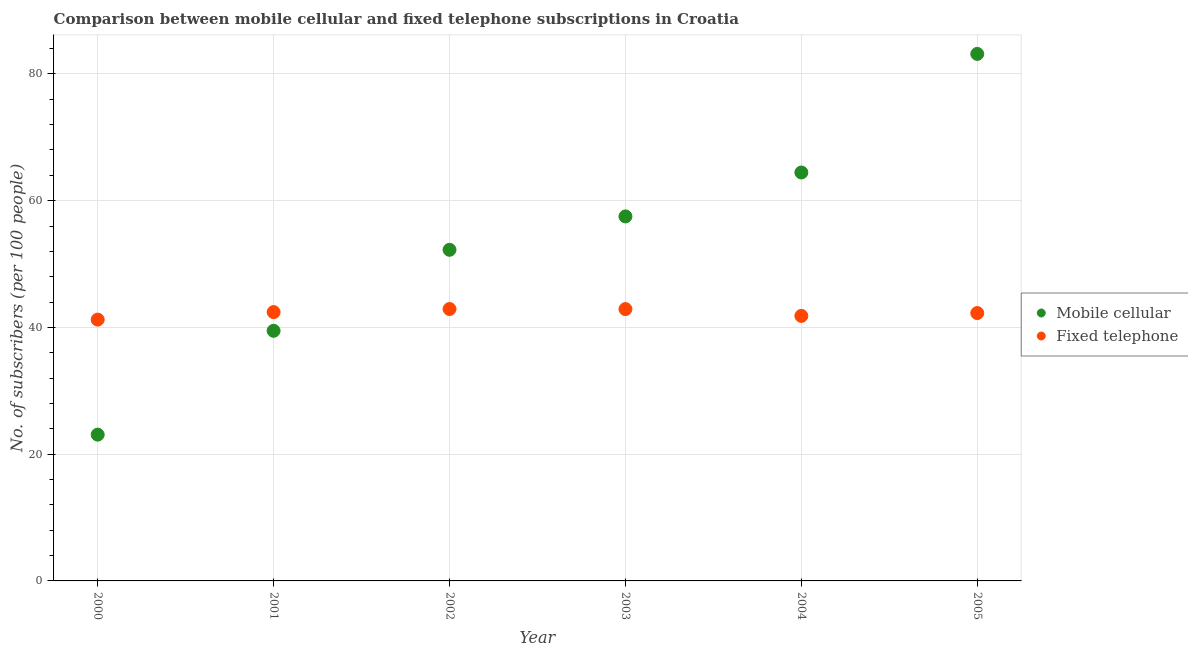Is the number of dotlines equal to the number of legend labels?
Your answer should be very brief. Yes. What is the number of fixed telephone subscribers in 2003?
Make the answer very short. 42.89. Across all years, what is the maximum number of mobile cellular subscribers?
Offer a terse response. 83.16. Across all years, what is the minimum number of fixed telephone subscribers?
Your answer should be very brief. 41.23. In which year was the number of fixed telephone subscribers maximum?
Keep it short and to the point. 2002. In which year was the number of fixed telephone subscribers minimum?
Provide a succinct answer. 2000. What is the total number of fixed telephone subscribers in the graph?
Your response must be concise. 253.53. What is the difference between the number of mobile cellular subscribers in 2000 and that in 2001?
Your answer should be compact. -16.38. What is the difference between the number of mobile cellular subscribers in 2001 and the number of fixed telephone subscribers in 2005?
Make the answer very short. -2.8. What is the average number of mobile cellular subscribers per year?
Offer a very short reply. 53.32. In the year 2000, what is the difference between the number of mobile cellular subscribers and number of fixed telephone subscribers?
Provide a succinct answer. -18.15. What is the ratio of the number of fixed telephone subscribers in 2000 to that in 2002?
Your answer should be very brief. 0.96. What is the difference between the highest and the second highest number of mobile cellular subscribers?
Give a very brief answer. 18.71. What is the difference between the highest and the lowest number of mobile cellular subscribers?
Keep it short and to the point. 60.08. In how many years, is the number of fixed telephone subscribers greater than the average number of fixed telephone subscribers taken over all years?
Offer a very short reply. 4. Is the sum of the number of fixed telephone subscribers in 2002 and 2005 greater than the maximum number of mobile cellular subscribers across all years?
Keep it short and to the point. Yes. Does the number of mobile cellular subscribers monotonically increase over the years?
Make the answer very short. Yes. How many dotlines are there?
Your answer should be very brief. 2. How many years are there in the graph?
Provide a succinct answer. 6. Are the values on the major ticks of Y-axis written in scientific E-notation?
Your response must be concise. No. Does the graph contain any zero values?
Make the answer very short. No. Does the graph contain grids?
Keep it short and to the point. Yes. Where does the legend appear in the graph?
Give a very brief answer. Center right. How many legend labels are there?
Your answer should be very brief. 2. What is the title of the graph?
Ensure brevity in your answer.  Comparison between mobile cellular and fixed telephone subscriptions in Croatia. What is the label or title of the X-axis?
Keep it short and to the point. Year. What is the label or title of the Y-axis?
Give a very brief answer. No. of subscribers (per 100 people). What is the No. of subscribers (per 100 people) in Mobile cellular in 2000?
Provide a short and direct response. 23.08. What is the No. of subscribers (per 100 people) of Fixed telephone in 2000?
Offer a terse response. 41.23. What is the No. of subscribers (per 100 people) of Mobile cellular in 2001?
Your answer should be compact. 39.47. What is the No. of subscribers (per 100 people) in Fixed telephone in 2001?
Ensure brevity in your answer.  42.42. What is the No. of subscribers (per 100 people) of Mobile cellular in 2002?
Keep it short and to the point. 52.25. What is the No. of subscribers (per 100 people) of Fixed telephone in 2002?
Ensure brevity in your answer.  42.9. What is the No. of subscribers (per 100 people) in Mobile cellular in 2003?
Provide a succinct answer. 57.52. What is the No. of subscribers (per 100 people) of Fixed telephone in 2003?
Offer a terse response. 42.89. What is the No. of subscribers (per 100 people) of Mobile cellular in 2004?
Offer a terse response. 64.45. What is the No. of subscribers (per 100 people) of Fixed telephone in 2004?
Offer a terse response. 41.82. What is the No. of subscribers (per 100 people) in Mobile cellular in 2005?
Ensure brevity in your answer.  83.16. What is the No. of subscribers (per 100 people) of Fixed telephone in 2005?
Keep it short and to the point. 42.26. Across all years, what is the maximum No. of subscribers (per 100 people) in Mobile cellular?
Provide a succinct answer. 83.16. Across all years, what is the maximum No. of subscribers (per 100 people) in Fixed telephone?
Make the answer very short. 42.9. Across all years, what is the minimum No. of subscribers (per 100 people) in Mobile cellular?
Your answer should be compact. 23.08. Across all years, what is the minimum No. of subscribers (per 100 people) in Fixed telephone?
Make the answer very short. 41.23. What is the total No. of subscribers (per 100 people) in Mobile cellular in the graph?
Ensure brevity in your answer.  319.92. What is the total No. of subscribers (per 100 people) in Fixed telephone in the graph?
Provide a short and direct response. 253.53. What is the difference between the No. of subscribers (per 100 people) in Mobile cellular in 2000 and that in 2001?
Keep it short and to the point. -16.38. What is the difference between the No. of subscribers (per 100 people) of Fixed telephone in 2000 and that in 2001?
Make the answer very short. -1.19. What is the difference between the No. of subscribers (per 100 people) in Mobile cellular in 2000 and that in 2002?
Make the answer very short. -29.17. What is the difference between the No. of subscribers (per 100 people) of Fixed telephone in 2000 and that in 2002?
Your response must be concise. -1.67. What is the difference between the No. of subscribers (per 100 people) of Mobile cellular in 2000 and that in 2003?
Provide a succinct answer. -34.43. What is the difference between the No. of subscribers (per 100 people) in Fixed telephone in 2000 and that in 2003?
Your answer should be very brief. -1.66. What is the difference between the No. of subscribers (per 100 people) of Mobile cellular in 2000 and that in 2004?
Ensure brevity in your answer.  -41.36. What is the difference between the No. of subscribers (per 100 people) of Fixed telephone in 2000 and that in 2004?
Your response must be concise. -0.59. What is the difference between the No. of subscribers (per 100 people) in Mobile cellular in 2000 and that in 2005?
Your answer should be compact. -60.08. What is the difference between the No. of subscribers (per 100 people) in Fixed telephone in 2000 and that in 2005?
Your answer should be very brief. -1.03. What is the difference between the No. of subscribers (per 100 people) in Mobile cellular in 2001 and that in 2002?
Provide a short and direct response. -12.78. What is the difference between the No. of subscribers (per 100 people) in Fixed telephone in 2001 and that in 2002?
Provide a succinct answer. -0.48. What is the difference between the No. of subscribers (per 100 people) of Mobile cellular in 2001 and that in 2003?
Keep it short and to the point. -18.05. What is the difference between the No. of subscribers (per 100 people) in Fixed telephone in 2001 and that in 2003?
Provide a short and direct response. -0.47. What is the difference between the No. of subscribers (per 100 people) of Mobile cellular in 2001 and that in 2004?
Your answer should be very brief. -24.98. What is the difference between the No. of subscribers (per 100 people) of Fixed telephone in 2001 and that in 2004?
Offer a very short reply. 0.6. What is the difference between the No. of subscribers (per 100 people) of Mobile cellular in 2001 and that in 2005?
Make the answer very short. -43.69. What is the difference between the No. of subscribers (per 100 people) of Fixed telephone in 2001 and that in 2005?
Give a very brief answer. 0.15. What is the difference between the No. of subscribers (per 100 people) in Mobile cellular in 2002 and that in 2003?
Offer a terse response. -5.27. What is the difference between the No. of subscribers (per 100 people) of Fixed telephone in 2002 and that in 2003?
Provide a succinct answer. 0.01. What is the difference between the No. of subscribers (per 100 people) of Mobile cellular in 2002 and that in 2004?
Offer a terse response. -12.2. What is the difference between the No. of subscribers (per 100 people) in Fixed telephone in 2002 and that in 2004?
Ensure brevity in your answer.  1.08. What is the difference between the No. of subscribers (per 100 people) in Mobile cellular in 2002 and that in 2005?
Keep it short and to the point. -30.91. What is the difference between the No. of subscribers (per 100 people) of Fixed telephone in 2002 and that in 2005?
Your response must be concise. 0.64. What is the difference between the No. of subscribers (per 100 people) in Mobile cellular in 2003 and that in 2004?
Keep it short and to the point. -6.93. What is the difference between the No. of subscribers (per 100 people) of Fixed telephone in 2003 and that in 2004?
Your answer should be compact. 1.07. What is the difference between the No. of subscribers (per 100 people) in Mobile cellular in 2003 and that in 2005?
Your answer should be compact. -25.64. What is the difference between the No. of subscribers (per 100 people) of Fixed telephone in 2003 and that in 2005?
Offer a terse response. 0.63. What is the difference between the No. of subscribers (per 100 people) of Mobile cellular in 2004 and that in 2005?
Ensure brevity in your answer.  -18.71. What is the difference between the No. of subscribers (per 100 people) in Fixed telephone in 2004 and that in 2005?
Offer a terse response. -0.45. What is the difference between the No. of subscribers (per 100 people) in Mobile cellular in 2000 and the No. of subscribers (per 100 people) in Fixed telephone in 2001?
Make the answer very short. -19.34. What is the difference between the No. of subscribers (per 100 people) in Mobile cellular in 2000 and the No. of subscribers (per 100 people) in Fixed telephone in 2002?
Your answer should be compact. -19.82. What is the difference between the No. of subscribers (per 100 people) of Mobile cellular in 2000 and the No. of subscribers (per 100 people) of Fixed telephone in 2003?
Ensure brevity in your answer.  -19.81. What is the difference between the No. of subscribers (per 100 people) in Mobile cellular in 2000 and the No. of subscribers (per 100 people) in Fixed telephone in 2004?
Provide a short and direct response. -18.74. What is the difference between the No. of subscribers (per 100 people) of Mobile cellular in 2000 and the No. of subscribers (per 100 people) of Fixed telephone in 2005?
Offer a very short reply. -19.18. What is the difference between the No. of subscribers (per 100 people) in Mobile cellular in 2001 and the No. of subscribers (per 100 people) in Fixed telephone in 2002?
Your answer should be compact. -3.44. What is the difference between the No. of subscribers (per 100 people) of Mobile cellular in 2001 and the No. of subscribers (per 100 people) of Fixed telephone in 2003?
Your response must be concise. -3.43. What is the difference between the No. of subscribers (per 100 people) in Mobile cellular in 2001 and the No. of subscribers (per 100 people) in Fixed telephone in 2004?
Your answer should be compact. -2.35. What is the difference between the No. of subscribers (per 100 people) of Mobile cellular in 2001 and the No. of subscribers (per 100 people) of Fixed telephone in 2005?
Offer a very short reply. -2.8. What is the difference between the No. of subscribers (per 100 people) in Mobile cellular in 2002 and the No. of subscribers (per 100 people) in Fixed telephone in 2003?
Make the answer very short. 9.36. What is the difference between the No. of subscribers (per 100 people) in Mobile cellular in 2002 and the No. of subscribers (per 100 people) in Fixed telephone in 2004?
Give a very brief answer. 10.43. What is the difference between the No. of subscribers (per 100 people) of Mobile cellular in 2002 and the No. of subscribers (per 100 people) of Fixed telephone in 2005?
Provide a short and direct response. 9.98. What is the difference between the No. of subscribers (per 100 people) of Mobile cellular in 2003 and the No. of subscribers (per 100 people) of Fixed telephone in 2004?
Your answer should be compact. 15.7. What is the difference between the No. of subscribers (per 100 people) in Mobile cellular in 2003 and the No. of subscribers (per 100 people) in Fixed telephone in 2005?
Your answer should be compact. 15.25. What is the difference between the No. of subscribers (per 100 people) of Mobile cellular in 2004 and the No. of subscribers (per 100 people) of Fixed telephone in 2005?
Your answer should be very brief. 22.18. What is the average No. of subscribers (per 100 people) in Mobile cellular per year?
Your response must be concise. 53.32. What is the average No. of subscribers (per 100 people) of Fixed telephone per year?
Offer a terse response. 42.26. In the year 2000, what is the difference between the No. of subscribers (per 100 people) of Mobile cellular and No. of subscribers (per 100 people) of Fixed telephone?
Make the answer very short. -18.15. In the year 2001, what is the difference between the No. of subscribers (per 100 people) of Mobile cellular and No. of subscribers (per 100 people) of Fixed telephone?
Offer a very short reply. -2.95. In the year 2002, what is the difference between the No. of subscribers (per 100 people) of Mobile cellular and No. of subscribers (per 100 people) of Fixed telephone?
Your response must be concise. 9.35. In the year 2003, what is the difference between the No. of subscribers (per 100 people) in Mobile cellular and No. of subscribers (per 100 people) in Fixed telephone?
Provide a succinct answer. 14.62. In the year 2004, what is the difference between the No. of subscribers (per 100 people) of Mobile cellular and No. of subscribers (per 100 people) of Fixed telephone?
Make the answer very short. 22.63. In the year 2005, what is the difference between the No. of subscribers (per 100 people) in Mobile cellular and No. of subscribers (per 100 people) in Fixed telephone?
Provide a short and direct response. 40.89. What is the ratio of the No. of subscribers (per 100 people) of Mobile cellular in 2000 to that in 2001?
Your answer should be very brief. 0.58. What is the ratio of the No. of subscribers (per 100 people) of Mobile cellular in 2000 to that in 2002?
Provide a short and direct response. 0.44. What is the ratio of the No. of subscribers (per 100 people) in Fixed telephone in 2000 to that in 2002?
Your response must be concise. 0.96. What is the ratio of the No. of subscribers (per 100 people) of Mobile cellular in 2000 to that in 2003?
Make the answer very short. 0.4. What is the ratio of the No. of subscribers (per 100 people) in Fixed telephone in 2000 to that in 2003?
Your answer should be compact. 0.96. What is the ratio of the No. of subscribers (per 100 people) of Mobile cellular in 2000 to that in 2004?
Your answer should be very brief. 0.36. What is the ratio of the No. of subscribers (per 100 people) of Fixed telephone in 2000 to that in 2004?
Provide a succinct answer. 0.99. What is the ratio of the No. of subscribers (per 100 people) in Mobile cellular in 2000 to that in 2005?
Your answer should be very brief. 0.28. What is the ratio of the No. of subscribers (per 100 people) of Fixed telephone in 2000 to that in 2005?
Make the answer very short. 0.98. What is the ratio of the No. of subscribers (per 100 people) of Mobile cellular in 2001 to that in 2002?
Offer a terse response. 0.76. What is the ratio of the No. of subscribers (per 100 people) in Fixed telephone in 2001 to that in 2002?
Provide a succinct answer. 0.99. What is the ratio of the No. of subscribers (per 100 people) in Mobile cellular in 2001 to that in 2003?
Keep it short and to the point. 0.69. What is the ratio of the No. of subscribers (per 100 people) in Fixed telephone in 2001 to that in 2003?
Offer a terse response. 0.99. What is the ratio of the No. of subscribers (per 100 people) in Mobile cellular in 2001 to that in 2004?
Offer a terse response. 0.61. What is the ratio of the No. of subscribers (per 100 people) in Fixed telephone in 2001 to that in 2004?
Your answer should be very brief. 1.01. What is the ratio of the No. of subscribers (per 100 people) of Mobile cellular in 2001 to that in 2005?
Ensure brevity in your answer.  0.47. What is the ratio of the No. of subscribers (per 100 people) of Mobile cellular in 2002 to that in 2003?
Provide a succinct answer. 0.91. What is the ratio of the No. of subscribers (per 100 people) of Mobile cellular in 2002 to that in 2004?
Make the answer very short. 0.81. What is the ratio of the No. of subscribers (per 100 people) of Fixed telephone in 2002 to that in 2004?
Provide a short and direct response. 1.03. What is the ratio of the No. of subscribers (per 100 people) in Mobile cellular in 2002 to that in 2005?
Keep it short and to the point. 0.63. What is the ratio of the No. of subscribers (per 100 people) of Fixed telephone in 2002 to that in 2005?
Your response must be concise. 1.02. What is the ratio of the No. of subscribers (per 100 people) of Mobile cellular in 2003 to that in 2004?
Keep it short and to the point. 0.89. What is the ratio of the No. of subscribers (per 100 people) in Fixed telephone in 2003 to that in 2004?
Keep it short and to the point. 1.03. What is the ratio of the No. of subscribers (per 100 people) in Mobile cellular in 2003 to that in 2005?
Ensure brevity in your answer.  0.69. What is the ratio of the No. of subscribers (per 100 people) of Fixed telephone in 2003 to that in 2005?
Your answer should be compact. 1.01. What is the ratio of the No. of subscribers (per 100 people) in Mobile cellular in 2004 to that in 2005?
Give a very brief answer. 0.78. What is the difference between the highest and the second highest No. of subscribers (per 100 people) in Mobile cellular?
Provide a short and direct response. 18.71. What is the difference between the highest and the second highest No. of subscribers (per 100 people) of Fixed telephone?
Your answer should be very brief. 0.01. What is the difference between the highest and the lowest No. of subscribers (per 100 people) in Mobile cellular?
Keep it short and to the point. 60.08. What is the difference between the highest and the lowest No. of subscribers (per 100 people) of Fixed telephone?
Make the answer very short. 1.67. 